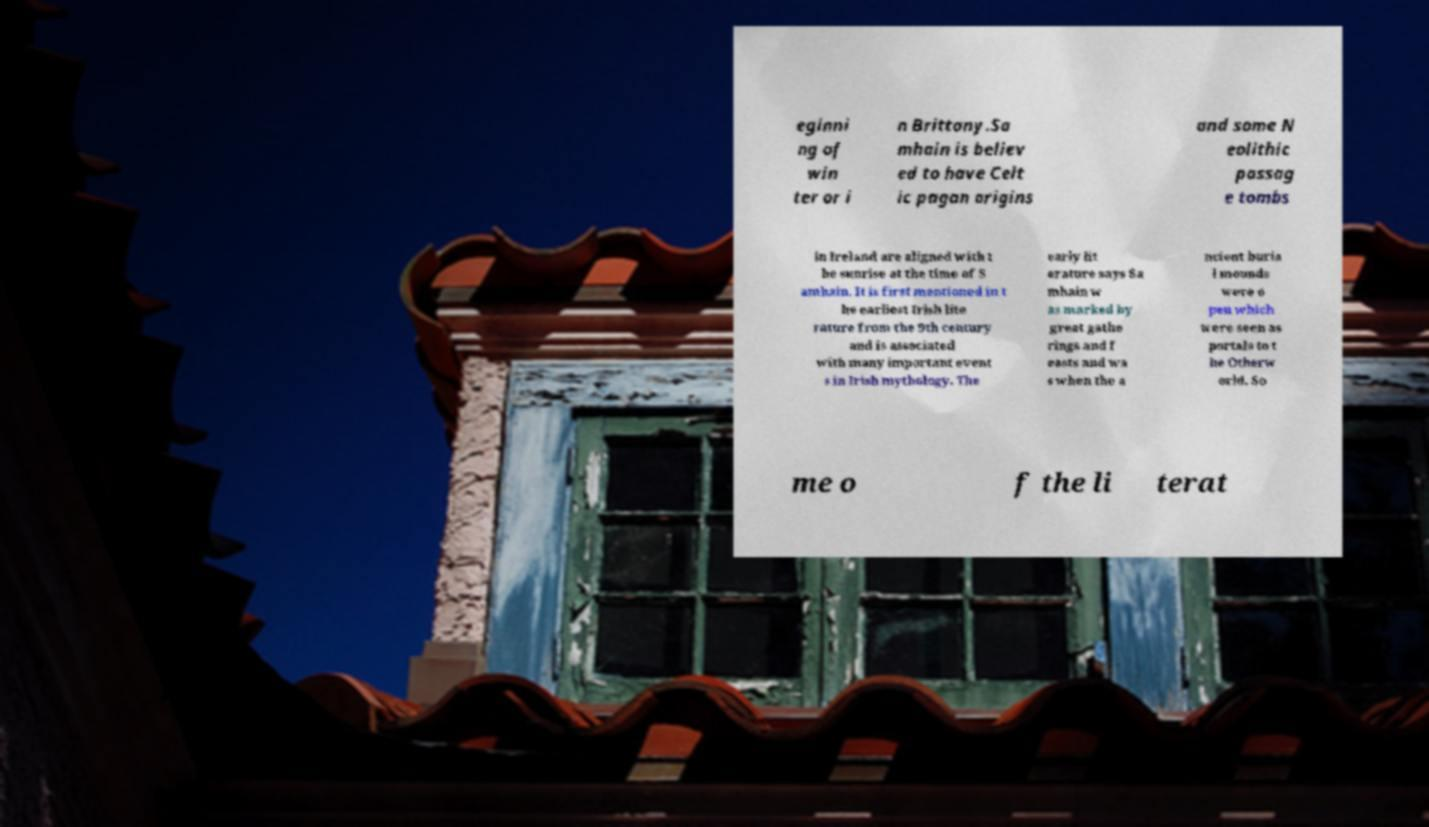Can you accurately transcribe the text from the provided image for me? eginni ng of win ter or i n Brittany.Sa mhain is believ ed to have Celt ic pagan origins and some N eolithic passag e tombs in Ireland are aligned with t he sunrise at the time of S amhain. It is first mentioned in t he earliest Irish lite rature from the 9th century and is associated with many important event s in Irish mythology. The early lit erature says Sa mhain w as marked by great gathe rings and f easts and wa s when the a ncient buria l mounds were o pen which were seen as portals to t he Otherw orld. So me o f the li terat 